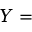<formula> <loc_0><loc_0><loc_500><loc_500>Y =</formula> 